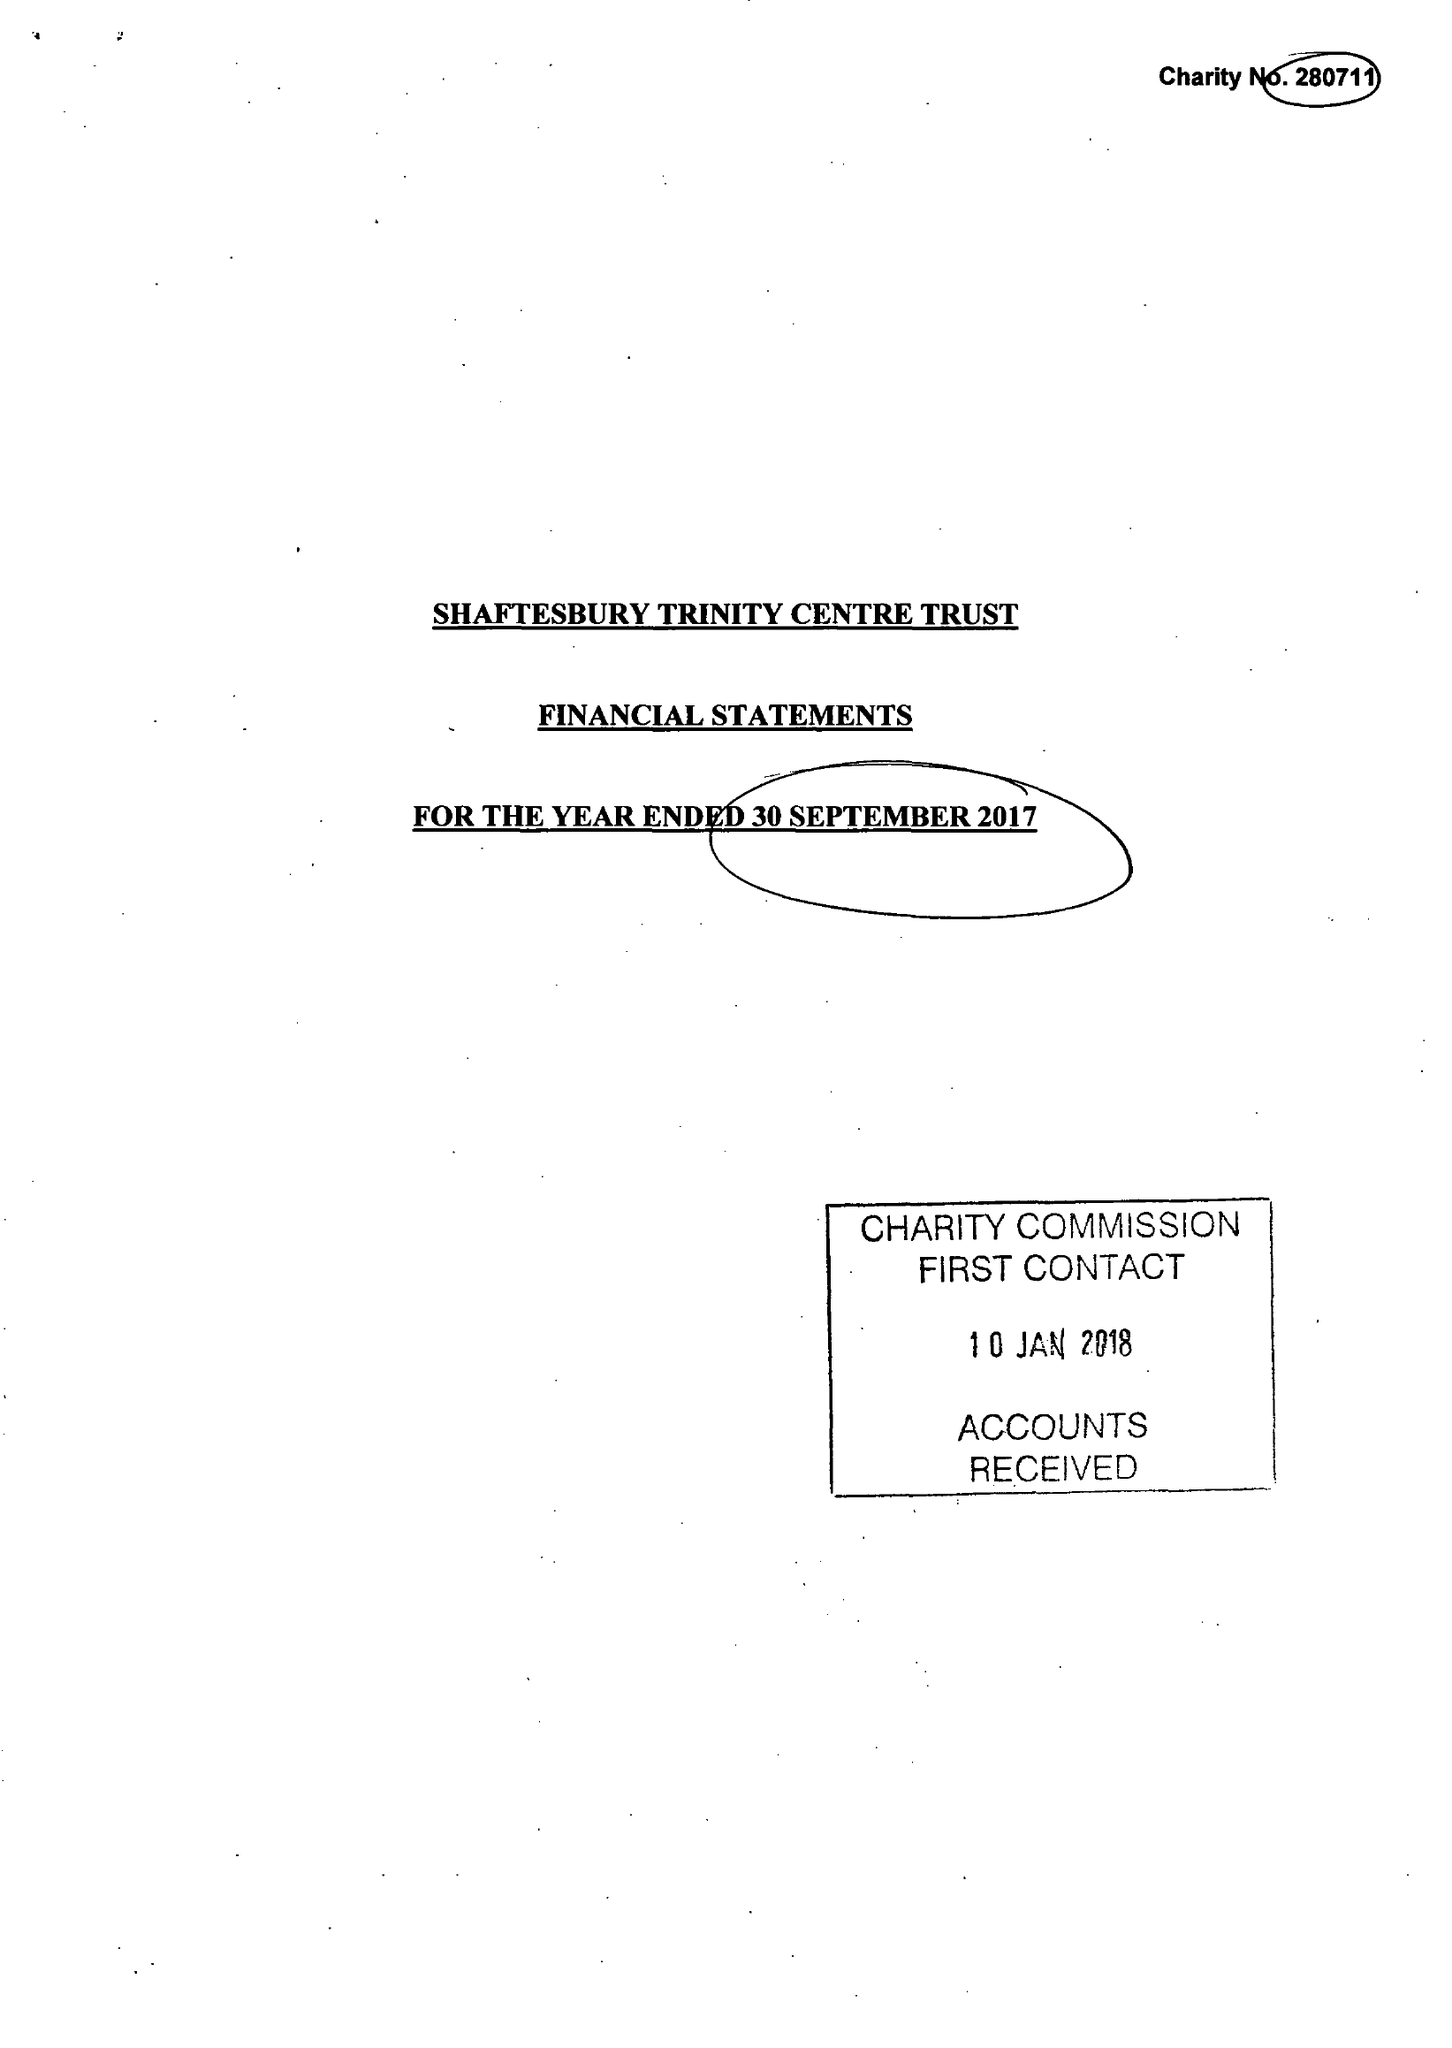What is the value for the income_annually_in_british_pounds?
Answer the question using a single word or phrase. 196700.00 